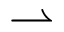Convert formula to latex. <formula><loc_0><loc_0><loc_500><loc_500>\rightharpoonup</formula> 